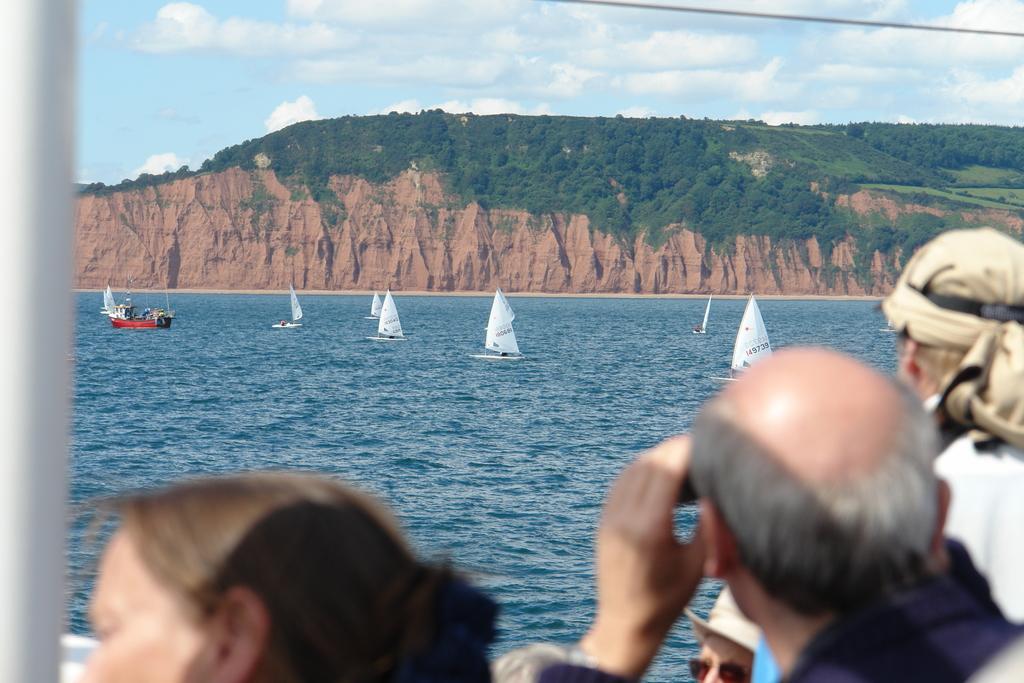Could you give a brief overview of what you see in this image? In this image at the bottom there are three persons who are standing, and in the center there is a river in the river there are some boats. And in the background there are some mountains and trees. On the top of the image there is sky, and on the left side there is one pole. 